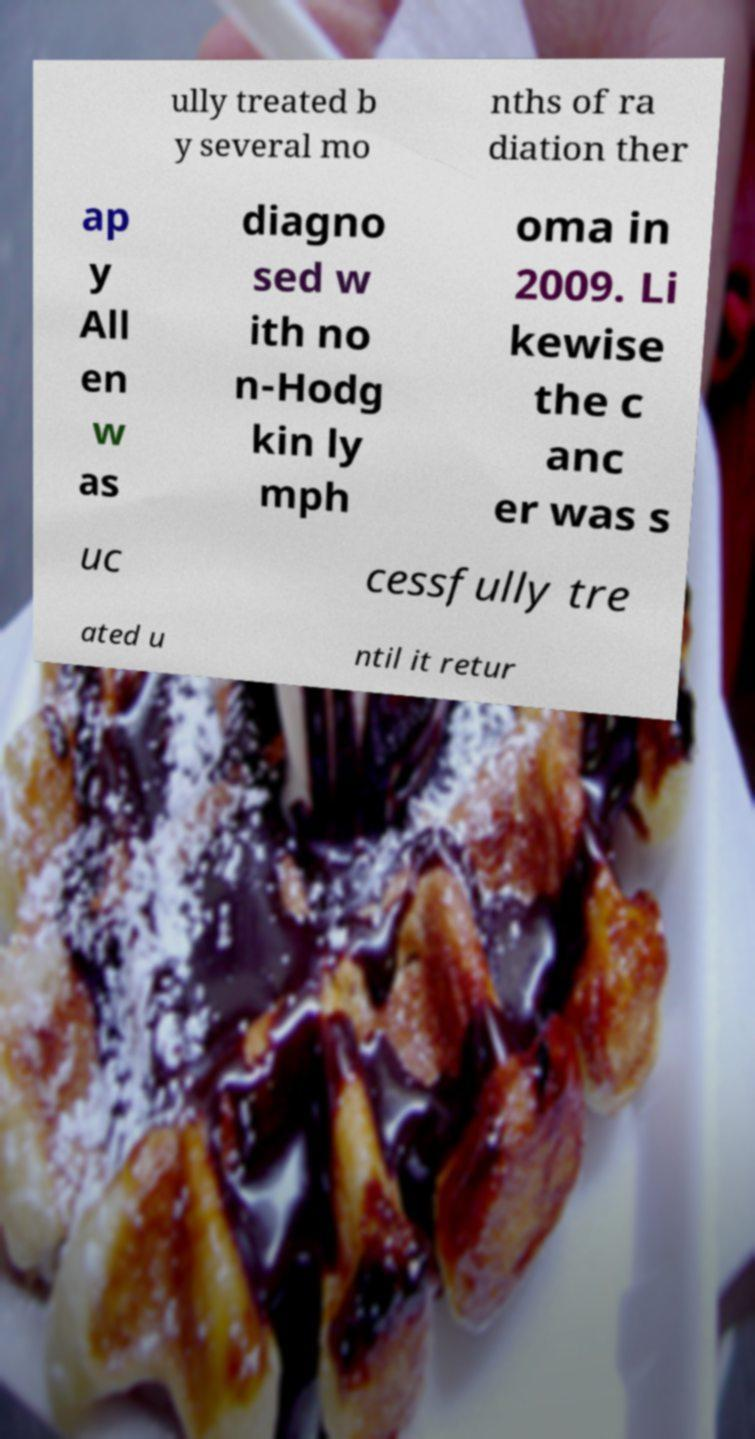Please identify and transcribe the text found in this image. ully treated b y several mo nths of ra diation ther ap y All en w as diagno sed w ith no n-Hodg kin ly mph oma in 2009. Li kewise the c anc er was s uc cessfully tre ated u ntil it retur 